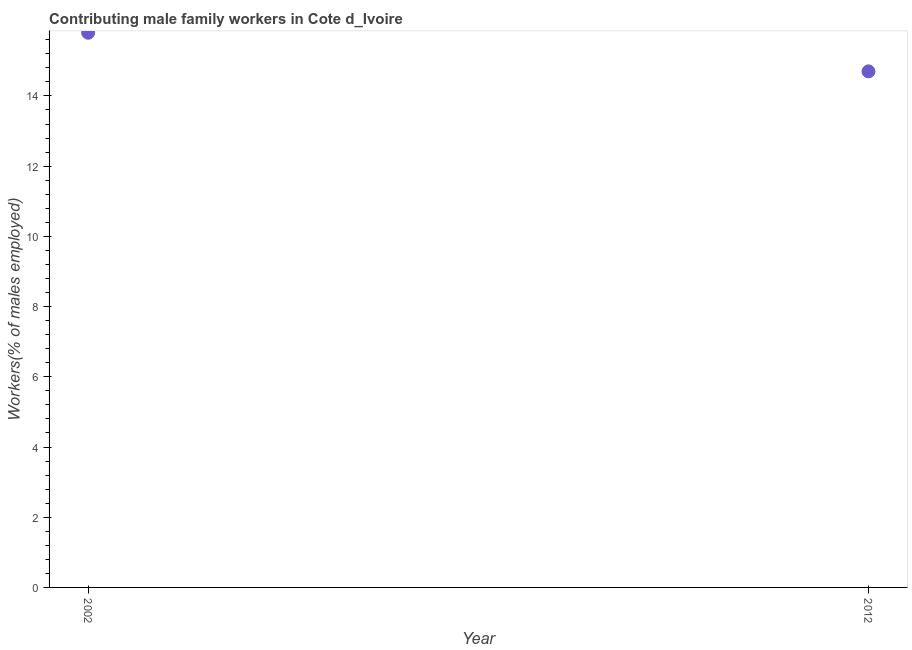What is the contributing male family workers in 2012?
Provide a short and direct response. 14.7. Across all years, what is the maximum contributing male family workers?
Keep it short and to the point. 15.8. Across all years, what is the minimum contributing male family workers?
Provide a succinct answer. 14.7. In which year was the contributing male family workers minimum?
Offer a very short reply. 2012. What is the sum of the contributing male family workers?
Offer a very short reply. 30.5. What is the difference between the contributing male family workers in 2002 and 2012?
Make the answer very short. 1.1. What is the average contributing male family workers per year?
Your response must be concise. 15.25. What is the median contributing male family workers?
Provide a succinct answer. 15.25. Do a majority of the years between 2012 and 2002 (inclusive) have contributing male family workers greater than 4.4 %?
Provide a succinct answer. No. What is the ratio of the contributing male family workers in 2002 to that in 2012?
Provide a short and direct response. 1.07. Is the contributing male family workers in 2002 less than that in 2012?
Your response must be concise. No. In how many years, is the contributing male family workers greater than the average contributing male family workers taken over all years?
Offer a terse response. 1. Does the contributing male family workers monotonically increase over the years?
Keep it short and to the point. No. How many dotlines are there?
Provide a short and direct response. 1. How many years are there in the graph?
Your response must be concise. 2. What is the difference between two consecutive major ticks on the Y-axis?
Provide a short and direct response. 2. What is the title of the graph?
Your response must be concise. Contributing male family workers in Cote d_Ivoire. What is the label or title of the X-axis?
Provide a succinct answer. Year. What is the label or title of the Y-axis?
Give a very brief answer. Workers(% of males employed). What is the Workers(% of males employed) in 2002?
Offer a very short reply. 15.8. What is the Workers(% of males employed) in 2012?
Offer a very short reply. 14.7. What is the difference between the Workers(% of males employed) in 2002 and 2012?
Keep it short and to the point. 1.1. What is the ratio of the Workers(% of males employed) in 2002 to that in 2012?
Offer a terse response. 1.07. 